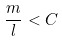<formula> <loc_0><loc_0><loc_500><loc_500>\frac { m } { l } < C</formula> 